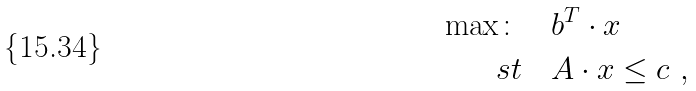Convert formula to latex. <formula><loc_0><loc_0><loc_500><loc_500>\max \colon & \quad b ^ { T } \cdot x \\ \ s t & \quad A \cdot x \leq c \ ,</formula> 